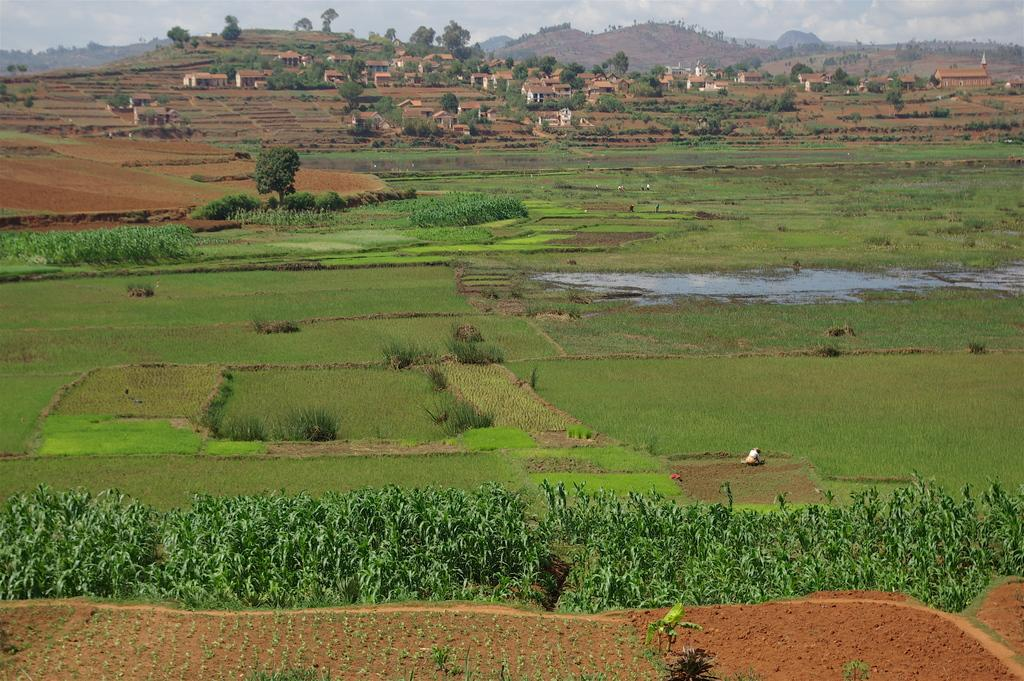What type of surface is covered with greenery in the image? The ground is covered with greenery in the image. What specific type of greenery can be seen on the ground? There are green plants and grass on the ground. What can be seen in the background of the image? There are trees and houses in the background. What type of calculator is visible on top of the trees in the image? There is no calculator present in the image, and no objects are visible on top of the trees. 